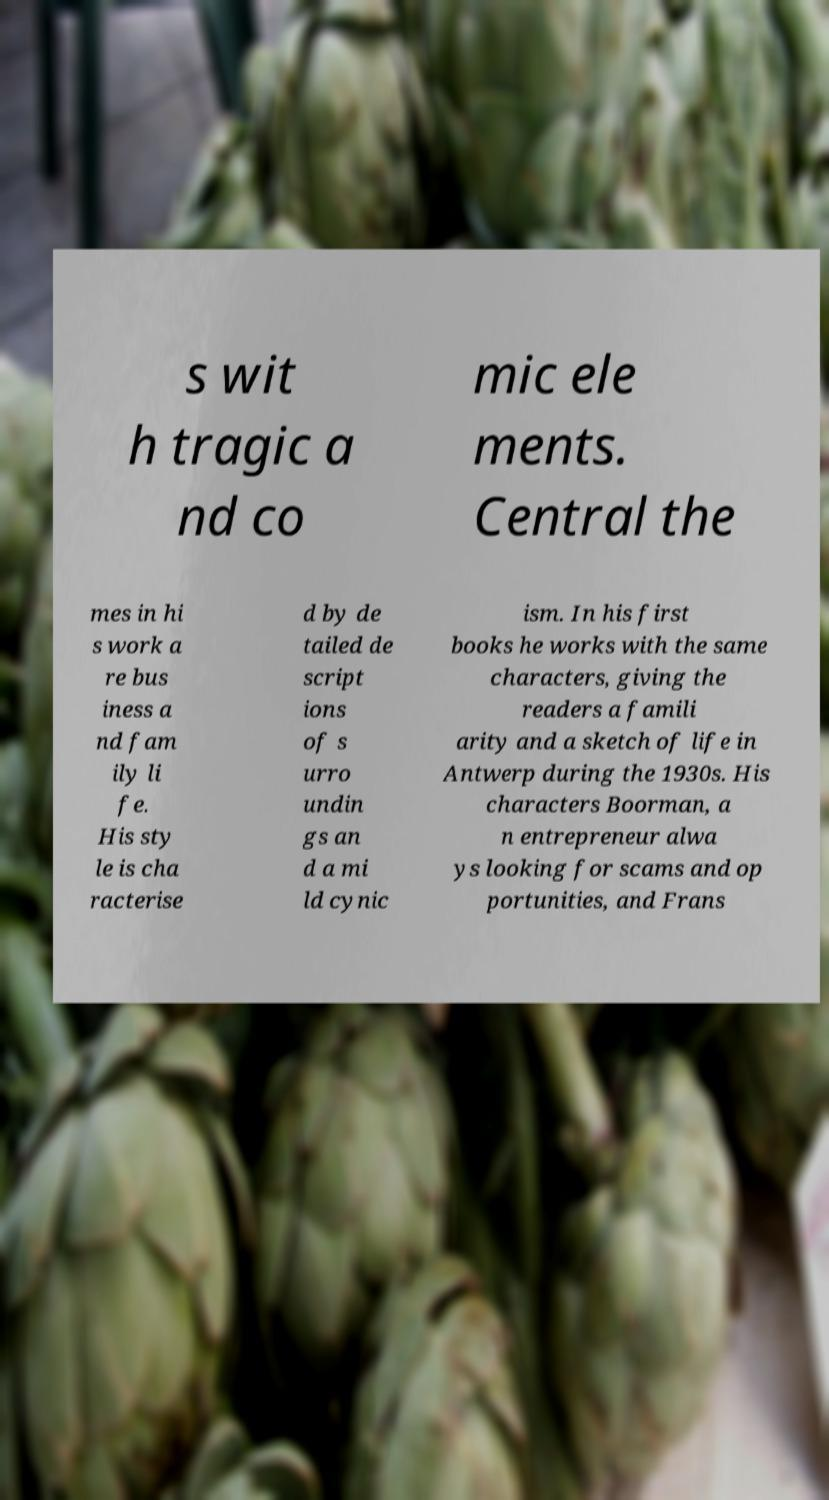Please identify and transcribe the text found in this image. s wit h tragic a nd co mic ele ments. Central the mes in hi s work a re bus iness a nd fam ily li fe. His sty le is cha racterise d by de tailed de script ions of s urro undin gs an d a mi ld cynic ism. In his first books he works with the same characters, giving the readers a famili arity and a sketch of life in Antwerp during the 1930s. His characters Boorman, a n entrepreneur alwa ys looking for scams and op portunities, and Frans 